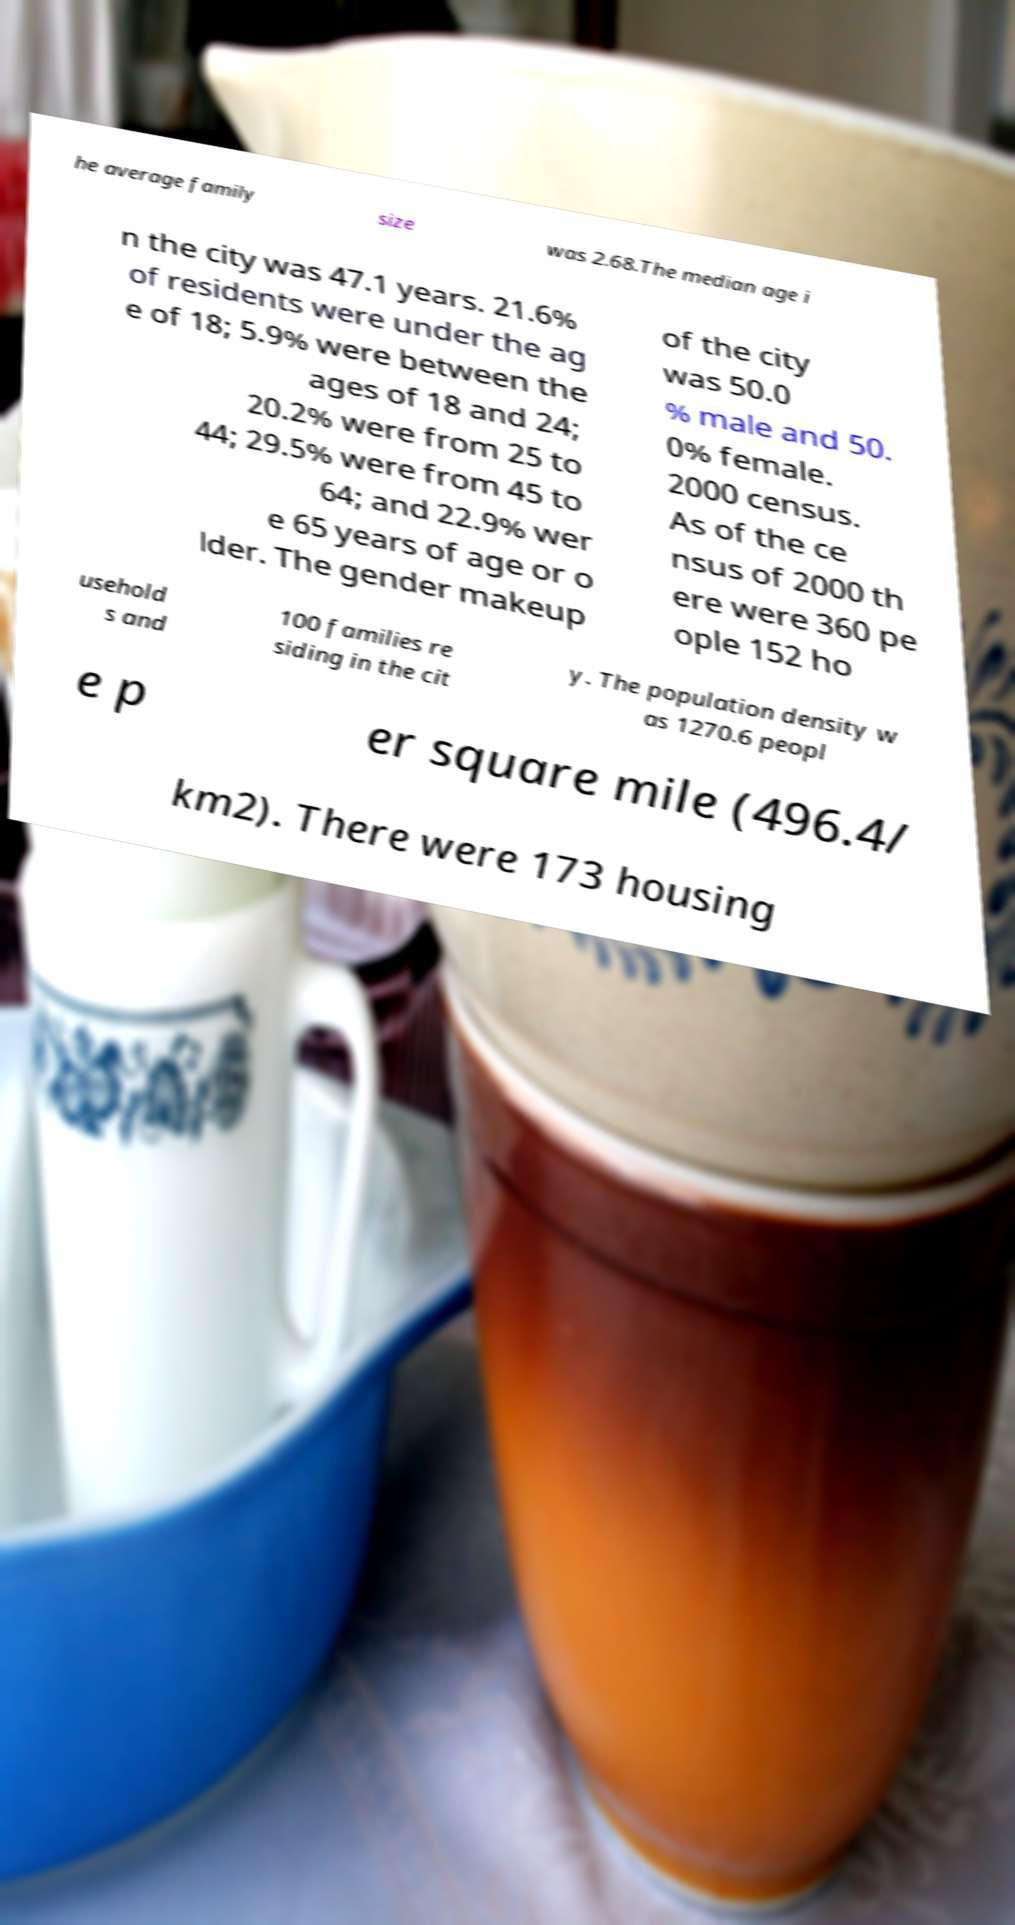Please read and relay the text visible in this image. What does it say? he average family size was 2.68.The median age i n the city was 47.1 years. 21.6% of residents were under the ag e of 18; 5.9% were between the ages of 18 and 24; 20.2% were from 25 to 44; 29.5% were from 45 to 64; and 22.9% wer e 65 years of age or o lder. The gender makeup of the city was 50.0 % male and 50. 0% female. 2000 census. As of the ce nsus of 2000 th ere were 360 pe ople 152 ho usehold s and 100 families re siding in the cit y. The population density w as 1270.6 peopl e p er square mile (496.4/ km2). There were 173 housing 